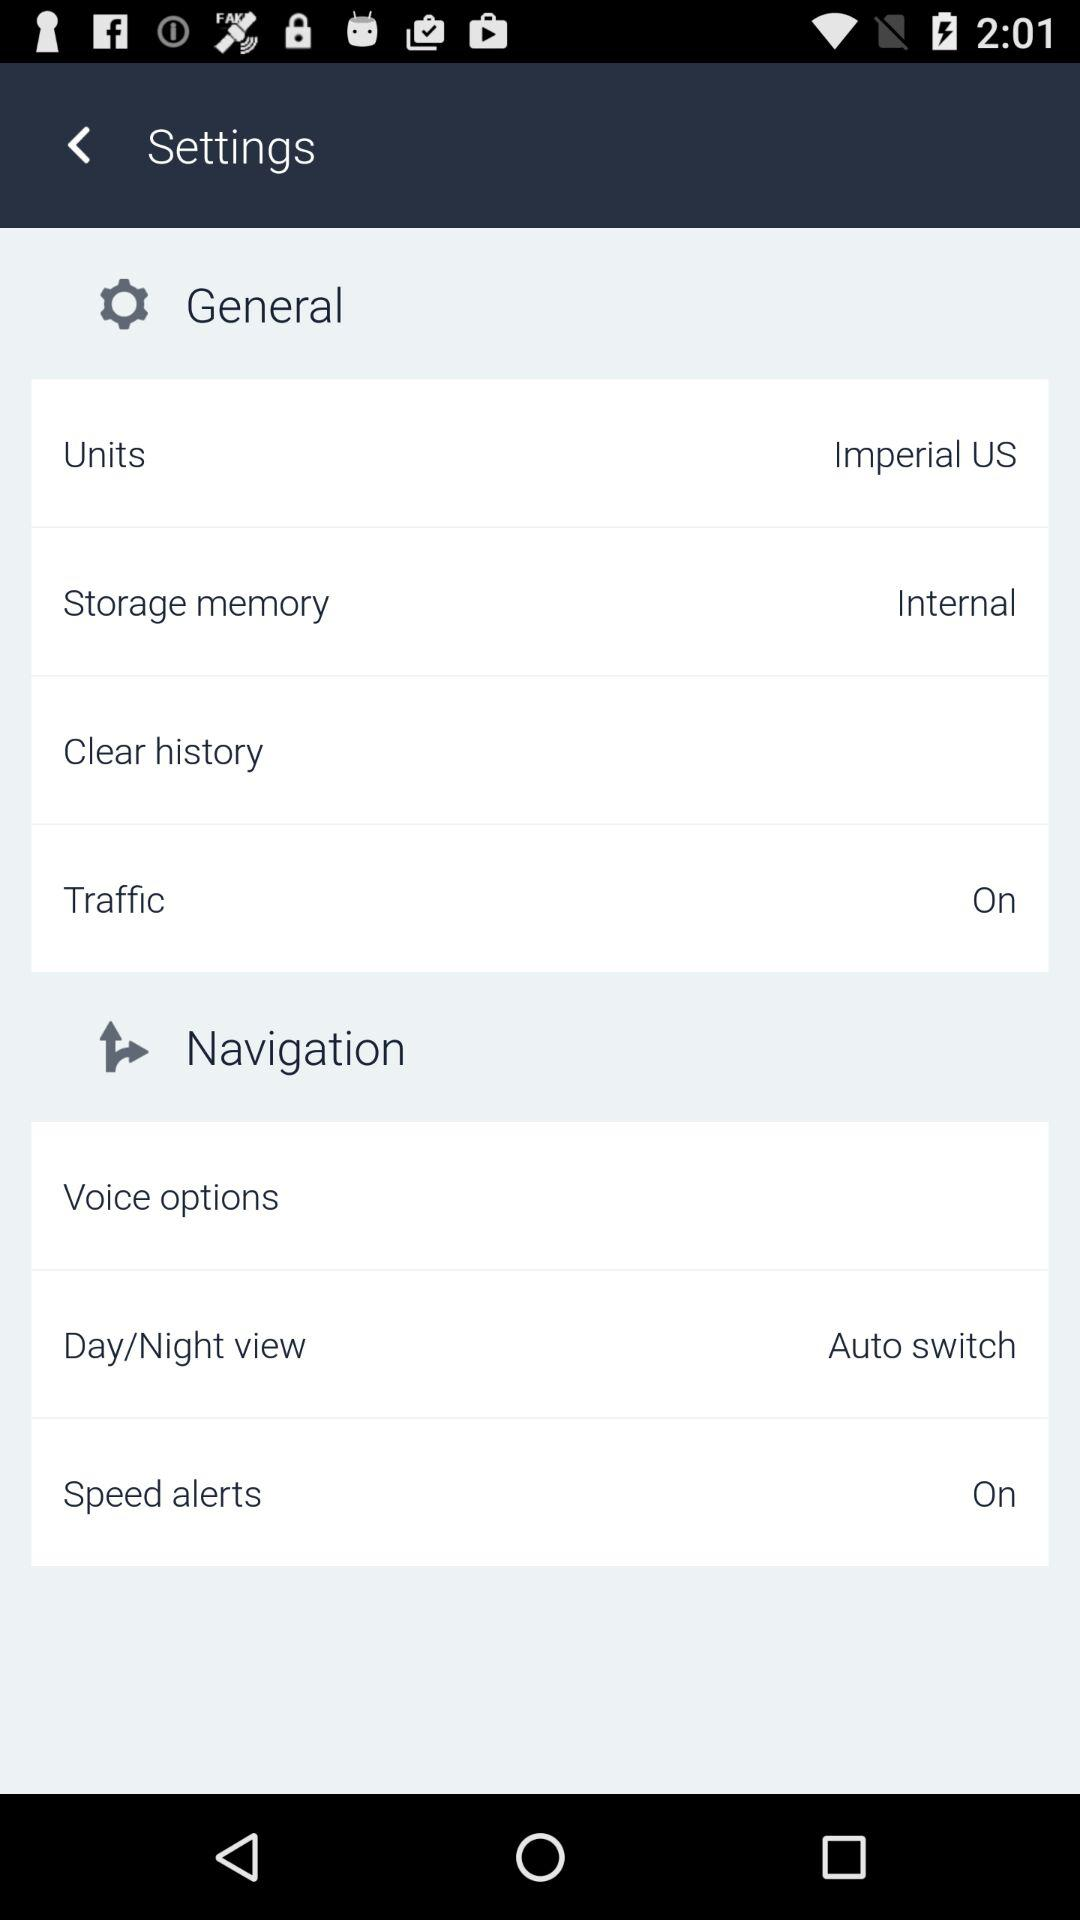How many settings have the text 'On'?
Answer the question using a single word or phrase. 2 